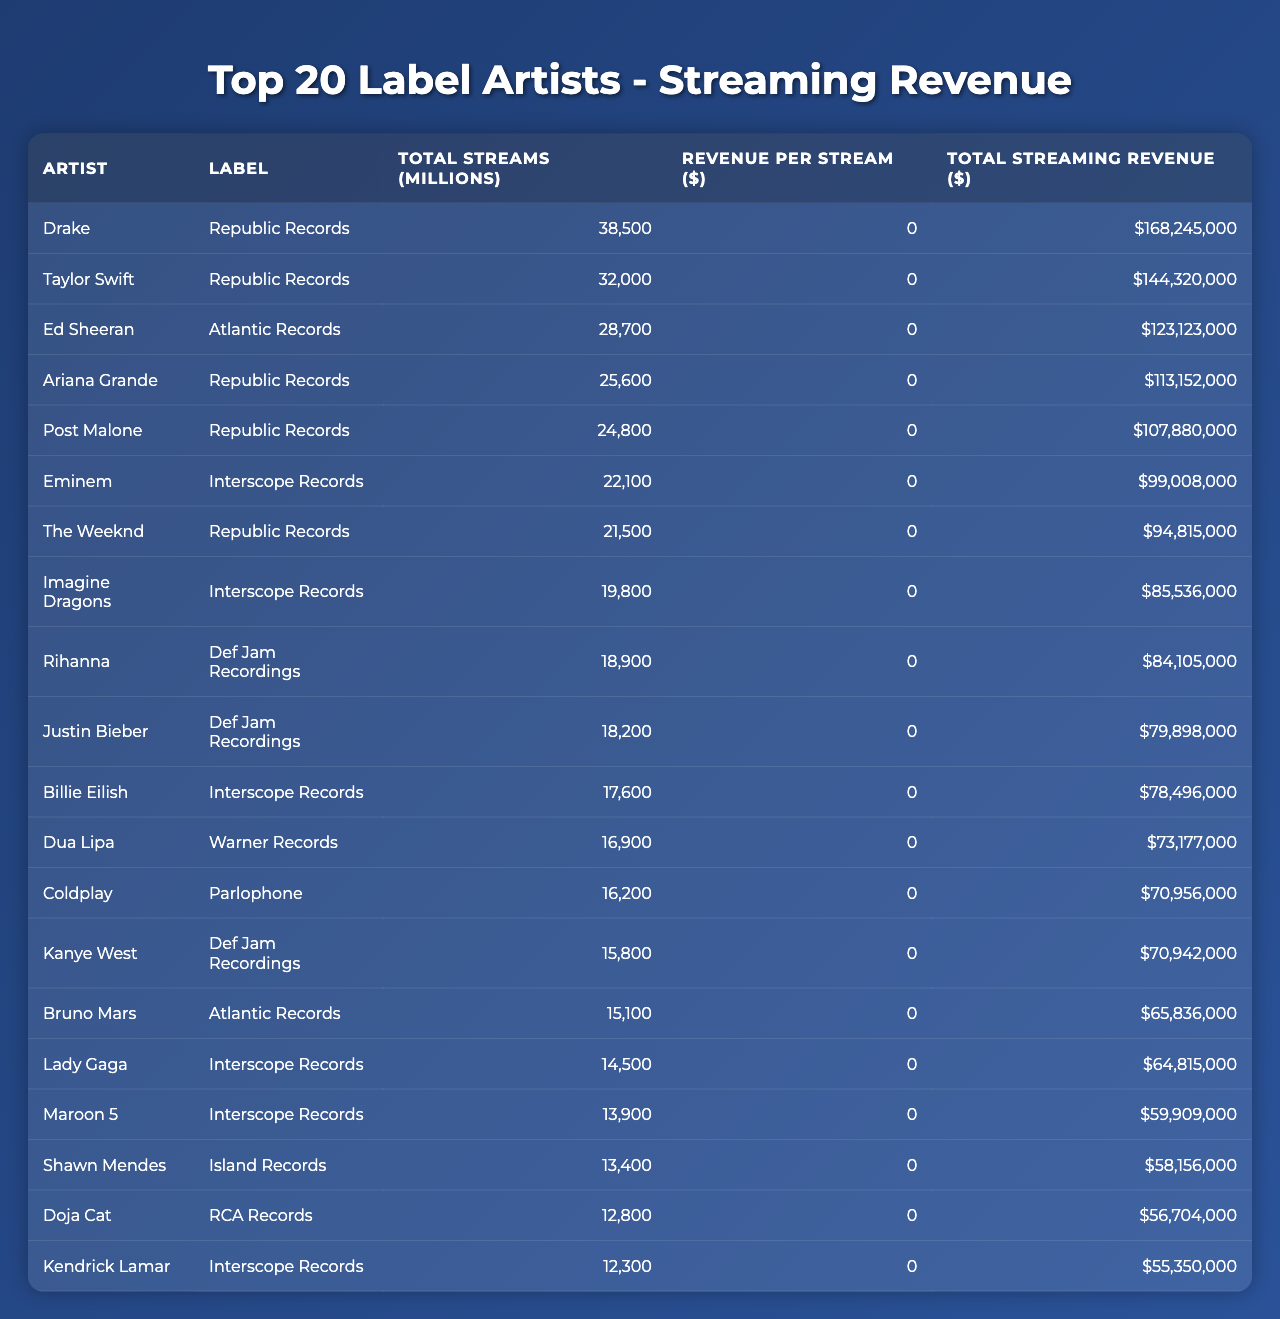What is the total streaming revenue generated by Drake? The table lists Drake's total streaming revenue, which is provided directly in the "Total Streaming Revenue ($)" column. For Drake, the amount is $168,245,000.
Answer: $168,245,000 Which artist has the highest revenue per stream? To determine this, we compare the "Revenue per Stream ($)" values for each artist in the table. The highest revenue per stream is for Kanye West at $0.00449.
Answer: $0.00449 How much total streaming revenue did Republic Records generate with its top artists? We sum the "Total Streaming Revenue ($)" for all Republic Records artists listed in the table: Drake ($168,245,000) + Taylor Swift ($144,320,000) + Ariana Grande ($113,152,000) + Post Malone ($107,880,000) + The Weeknd ($94,815,000), which equals $628,412,000.
Answer: $628,412,000 Is there any artist in the table with more than 30,000 million total streams? We can check the "Total Streams (millions)" column to see if any artist is above 30,000 million. The artists listed above this threshold are Drake (38,500) and Taylor Swift (32,000), confirming the existence of artists over 30,000 million streams.
Answer: Yes What is the average revenue per stream for the artists from Interscope Records? We first determine the revenue per stream for Interscope artists listed in the table: Eminem ($0.00448), Billie Eilish ($0.00446), Lady Gaga ($0.00447), Maroon 5 ($0.00431), Kendrick Lamar ($0.00450). The average is calculated as (0.00448 + 0.00446 + 0.00447 + 0.00431 + 0.00450) / 5, resulting in $0.004434.
Answer: $0.004434 Which artist generated the least total streaming revenue and what was the amount? We examine the "Total Streaming Revenue ($)" column to find the lowest value. The artist with the least revenue is Doja Cat, with total streaming revenue amounting to $56,704,000.
Answer: $56,704,000 What is the difference in total streaming revenue between the highest and the lowest artist? The highest total streaming revenue is Drake's ($168,245,000) and the lowest is Doja Cat's ($56,704,000). The difference is calculated as $168,245,000 - $56,704,000, which equals $111,541,000.
Answer: $111,541,000 How many artists in the table belong to Atlantic Records, and what is their total streaming revenue? We check the table for Atlantic Records artists: Ed Sheeran ($123,123,000) and Bruno Mars ($65,836,000). There are 2 artists, and their total revenue is $123,123,000 + $65,836,000 = $188,959,000.
Answer: 2 artists, $188,959,000 Which label has the artist with the second highest total streams, and who is that artist? By referencing the "Total Streams (millions)" column, we find that Taylor Swift has the second highest streams at 32,000 million, and she is associated with Republic Records.
Answer: Republic Records, Taylor Swift What percentage of total streams does Rihanna contribute out of the total streams by the top 20 artists? The total streams for all listed artists in the table can be calculated by summing their amounts. Rihanna has 18,900 million streams, so to find the percentage, we use (18,900 / total streams) * 100. The total is 38500 + 32000 + 28700 + ... + 12300 = 359,300 million streams. Thus, the percentage is (18,900 / 359,300) * 100 = 5.26%.
Answer: 5.26% 